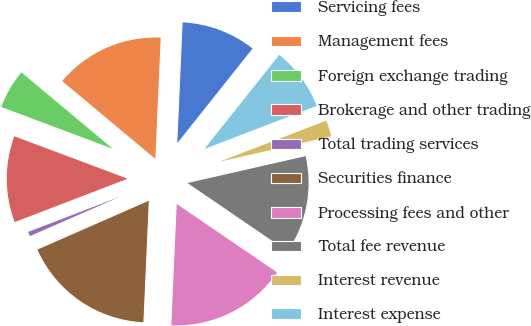Convert chart to OTSL. <chart><loc_0><loc_0><loc_500><loc_500><pie_chart><fcel>Servicing fees<fcel>Management fees<fcel>Foreign exchange trading<fcel>Brokerage and other trading<fcel>Total trading services<fcel>Securities finance<fcel>Processing fees and other<fcel>Total fee revenue<fcel>Interest revenue<fcel>Interest expense<nl><fcel>10.0%<fcel>14.63%<fcel>5.37%<fcel>11.54%<fcel>0.74%<fcel>17.72%<fcel>16.18%<fcel>13.09%<fcel>2.28%<fcel>8.46%<nl></chart> 